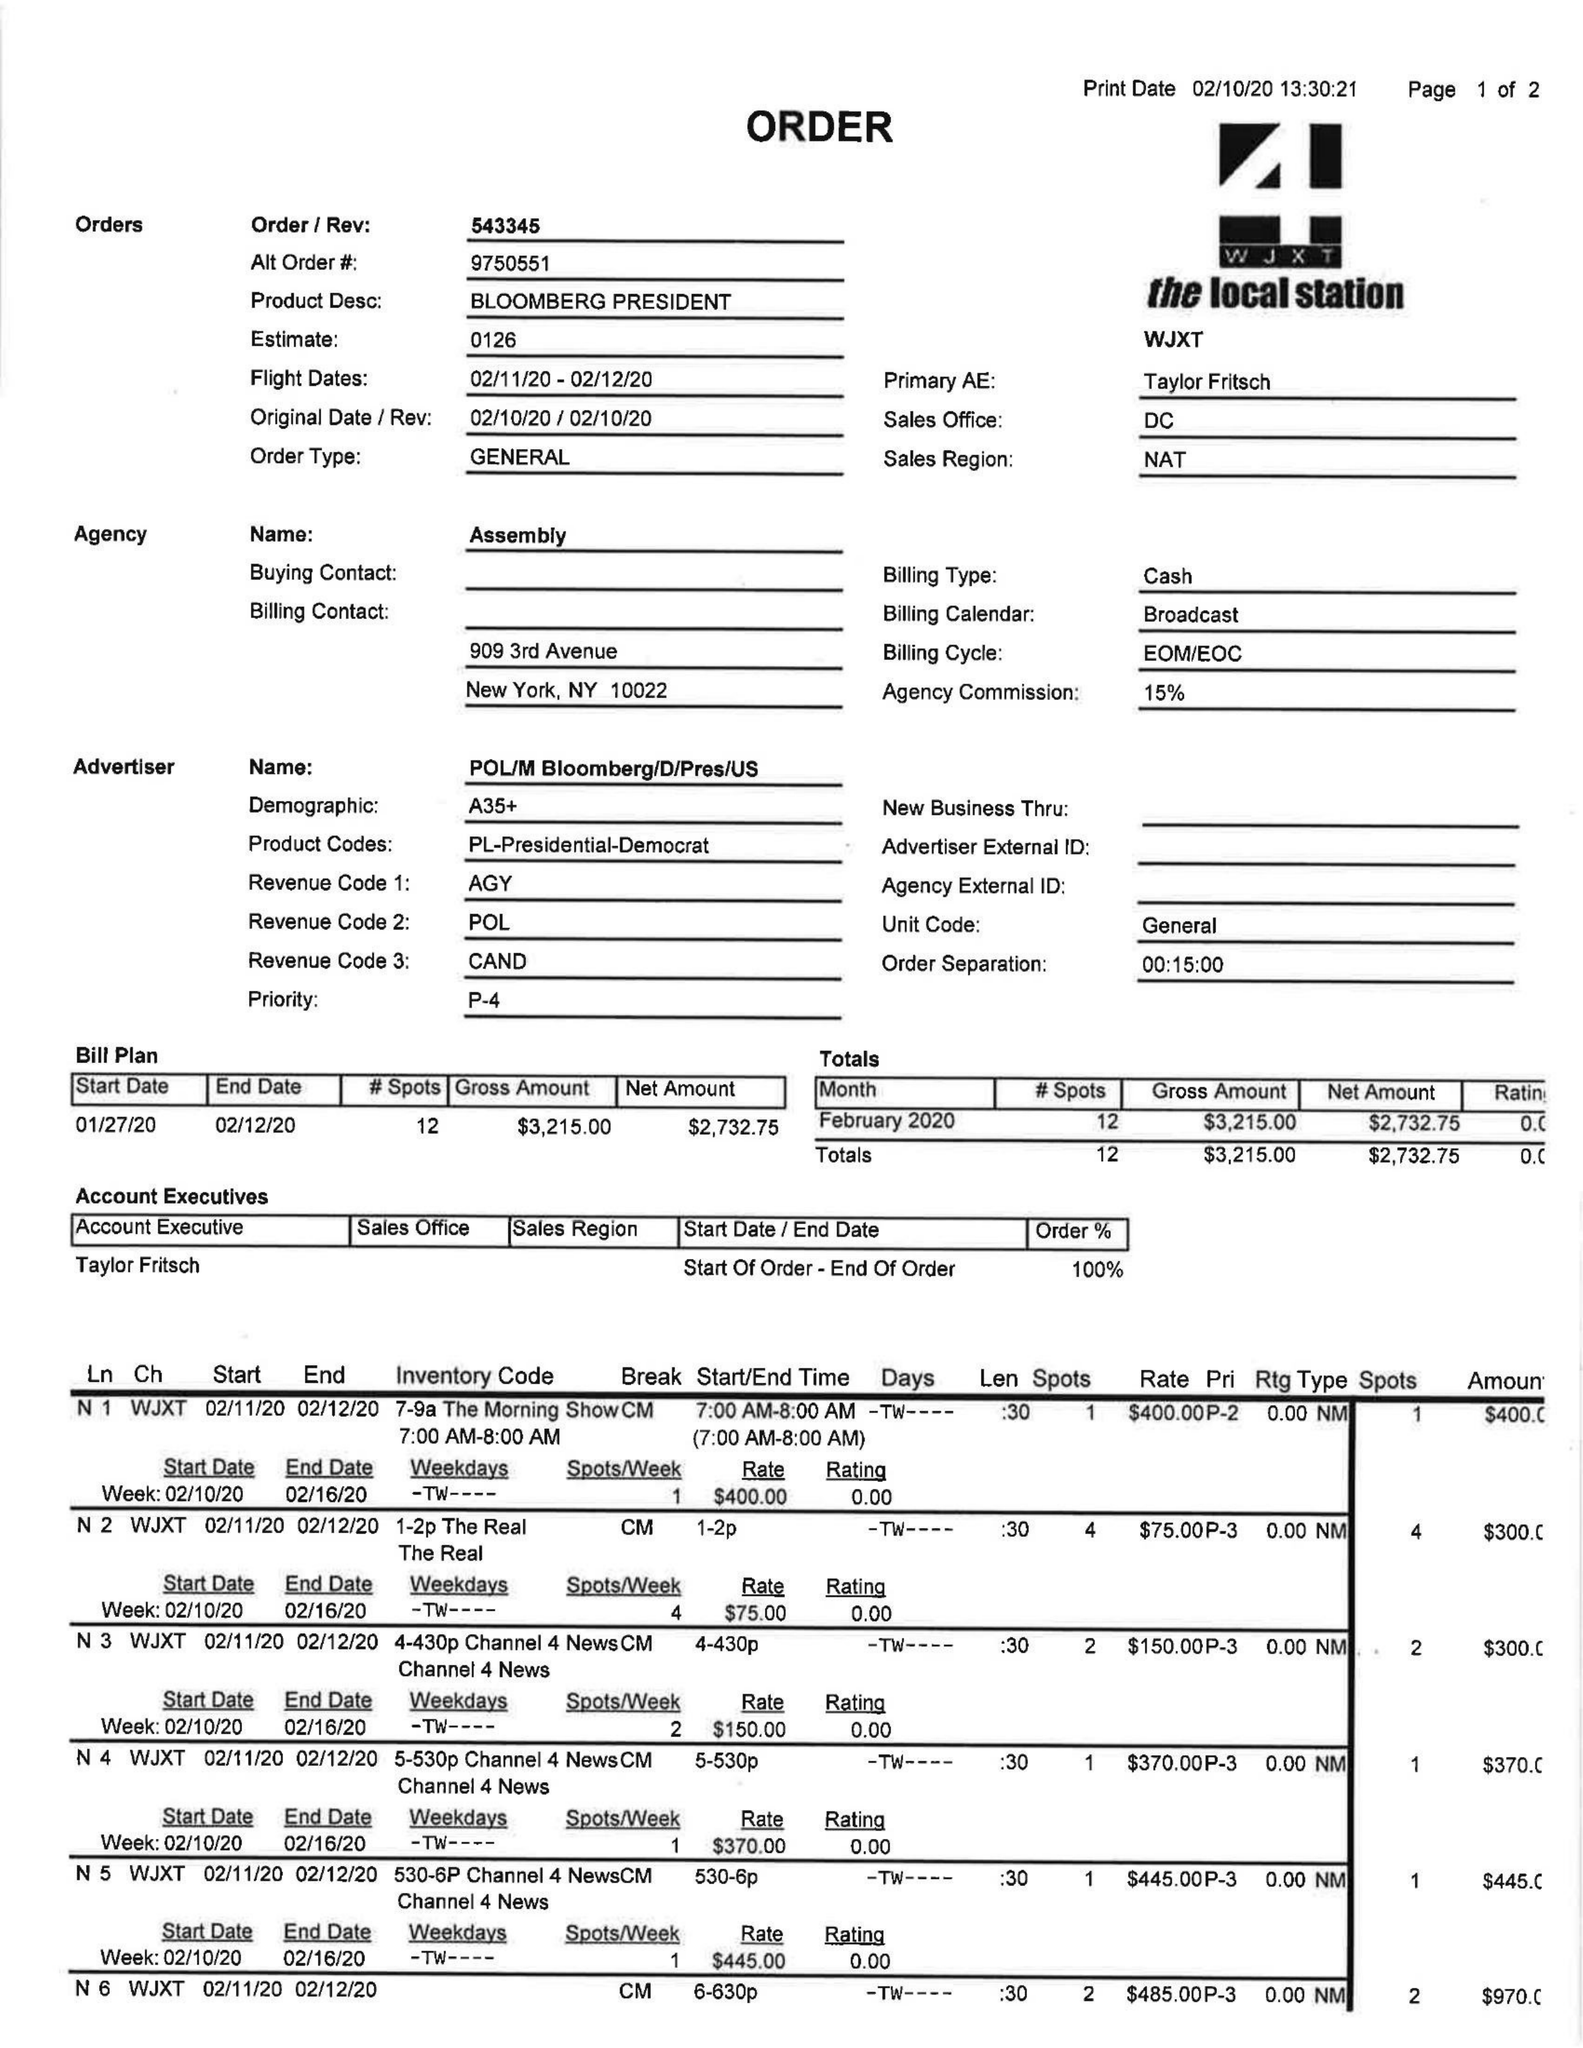What is the value for the advertiser?
Answer the question using a single word or phrase. POL/MBLOOMBERG/D/PRES/US 